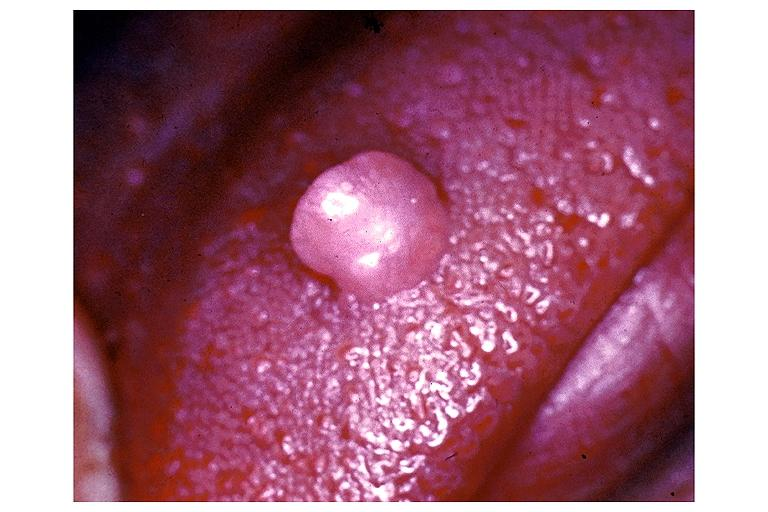what is present?
Answer the question using a single word or phrase. Oral 